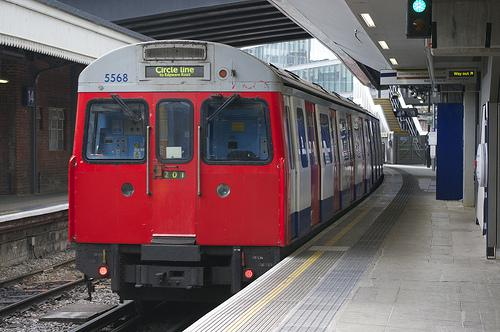Question: where is the train?
Choices:
A. On train tracks.
B. At the station.
C. Running late.
D. On time.
Answer with the letter. Answer: A Question: where was the photo taken?
Choices:
A. At a bus station.
B. At a train station.
C. At a subway station.
D. In a taxi.
Answer with the letter. Answer: B Question: what is red and gray?
Choices:
A. Train.
B. Bus.
C. Boat.
D. Motorcycle.
Answer with the letter. Answer: A Question: what is lit green?
Choices:
A. The neon light.
B. The christmas lights.
C. The light.
D. Traffic light.
Answer with the letter. Answer: D Question: where are windows?
Choices:
A. On a cruise ship.
B. In a building.
C. In a car.
D. On a train.
Answer with the letter. Answer: D Question: what is yellow?
Choices:
A. Canary.
B. Line on ground.
C. School bus.
D. The sun.
Answer with the letter. Answer: B 